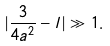<formula> <loc_0><loc_0><loc_500><loc_500>| \frac { 3 } { 4 a ^ { 2 } } - l | \gg 1 .</formula> 